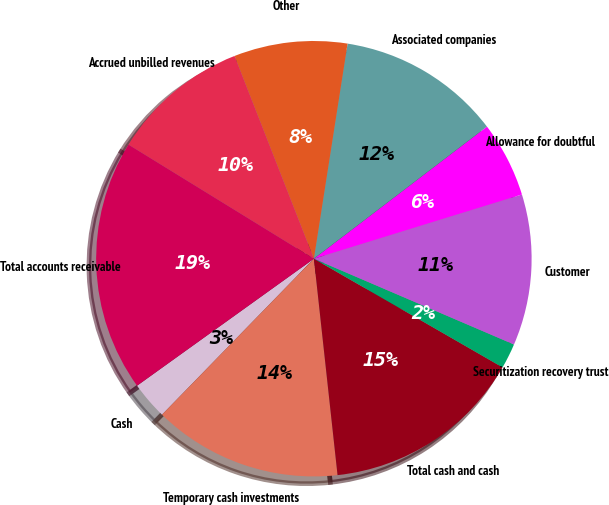<chart> <loc_0><loc_0><loc_500><loc_500><pie_chart><fcel>Cash<fcel>Temporary cash investments<fcel>Total cash and cash<fcel>Securitization recovery trust<fcel>Customer<fcel>Allowance for doubtful<fcel>Associated companies<fcel>Other<fcel>Accrued unbilled revenues<fcel>Total accounts receivable<nl><fcel>2.8%<fcel>14.02%<fcel>14.95%<fcel>1.87%<fcel>11.21%<fcel>5.61%<fcel>12.15%<fcel>8.41%<fcel>10.28%<fcel>18.69%<nl></chart> 